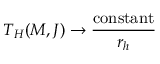Convert formula to latex. <formula><loc_0><loc_0><loc_500><loc_500>T _ { H } ( M , J ) \rightarrow \frac { c o n s t a n t } { r _ { h } }</formula> 